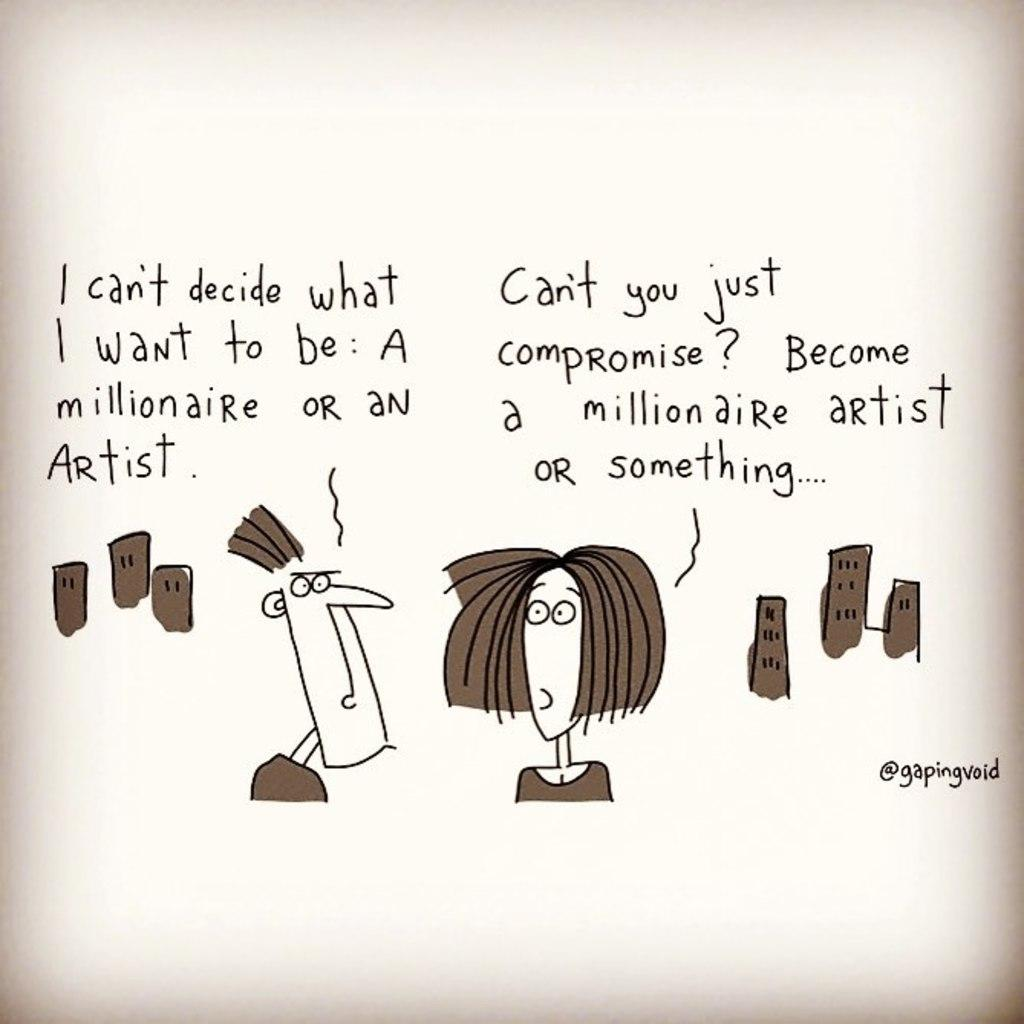What is depicted in the sketch in the image? The sketch in the image contains a man and a woman. What can be observed about the buildings in the image? The buildings in the image are brown-colored. What is the color combination of the words and the surface they are written on? The words are written in black color on a cream-colored surface. What type of gate can be seen in the image? There is no gate present in the image. What is the woman holding on a plate in the image? There is no plate or any object being held by the woman in the image, as it is a sketch of a man and a woman. 